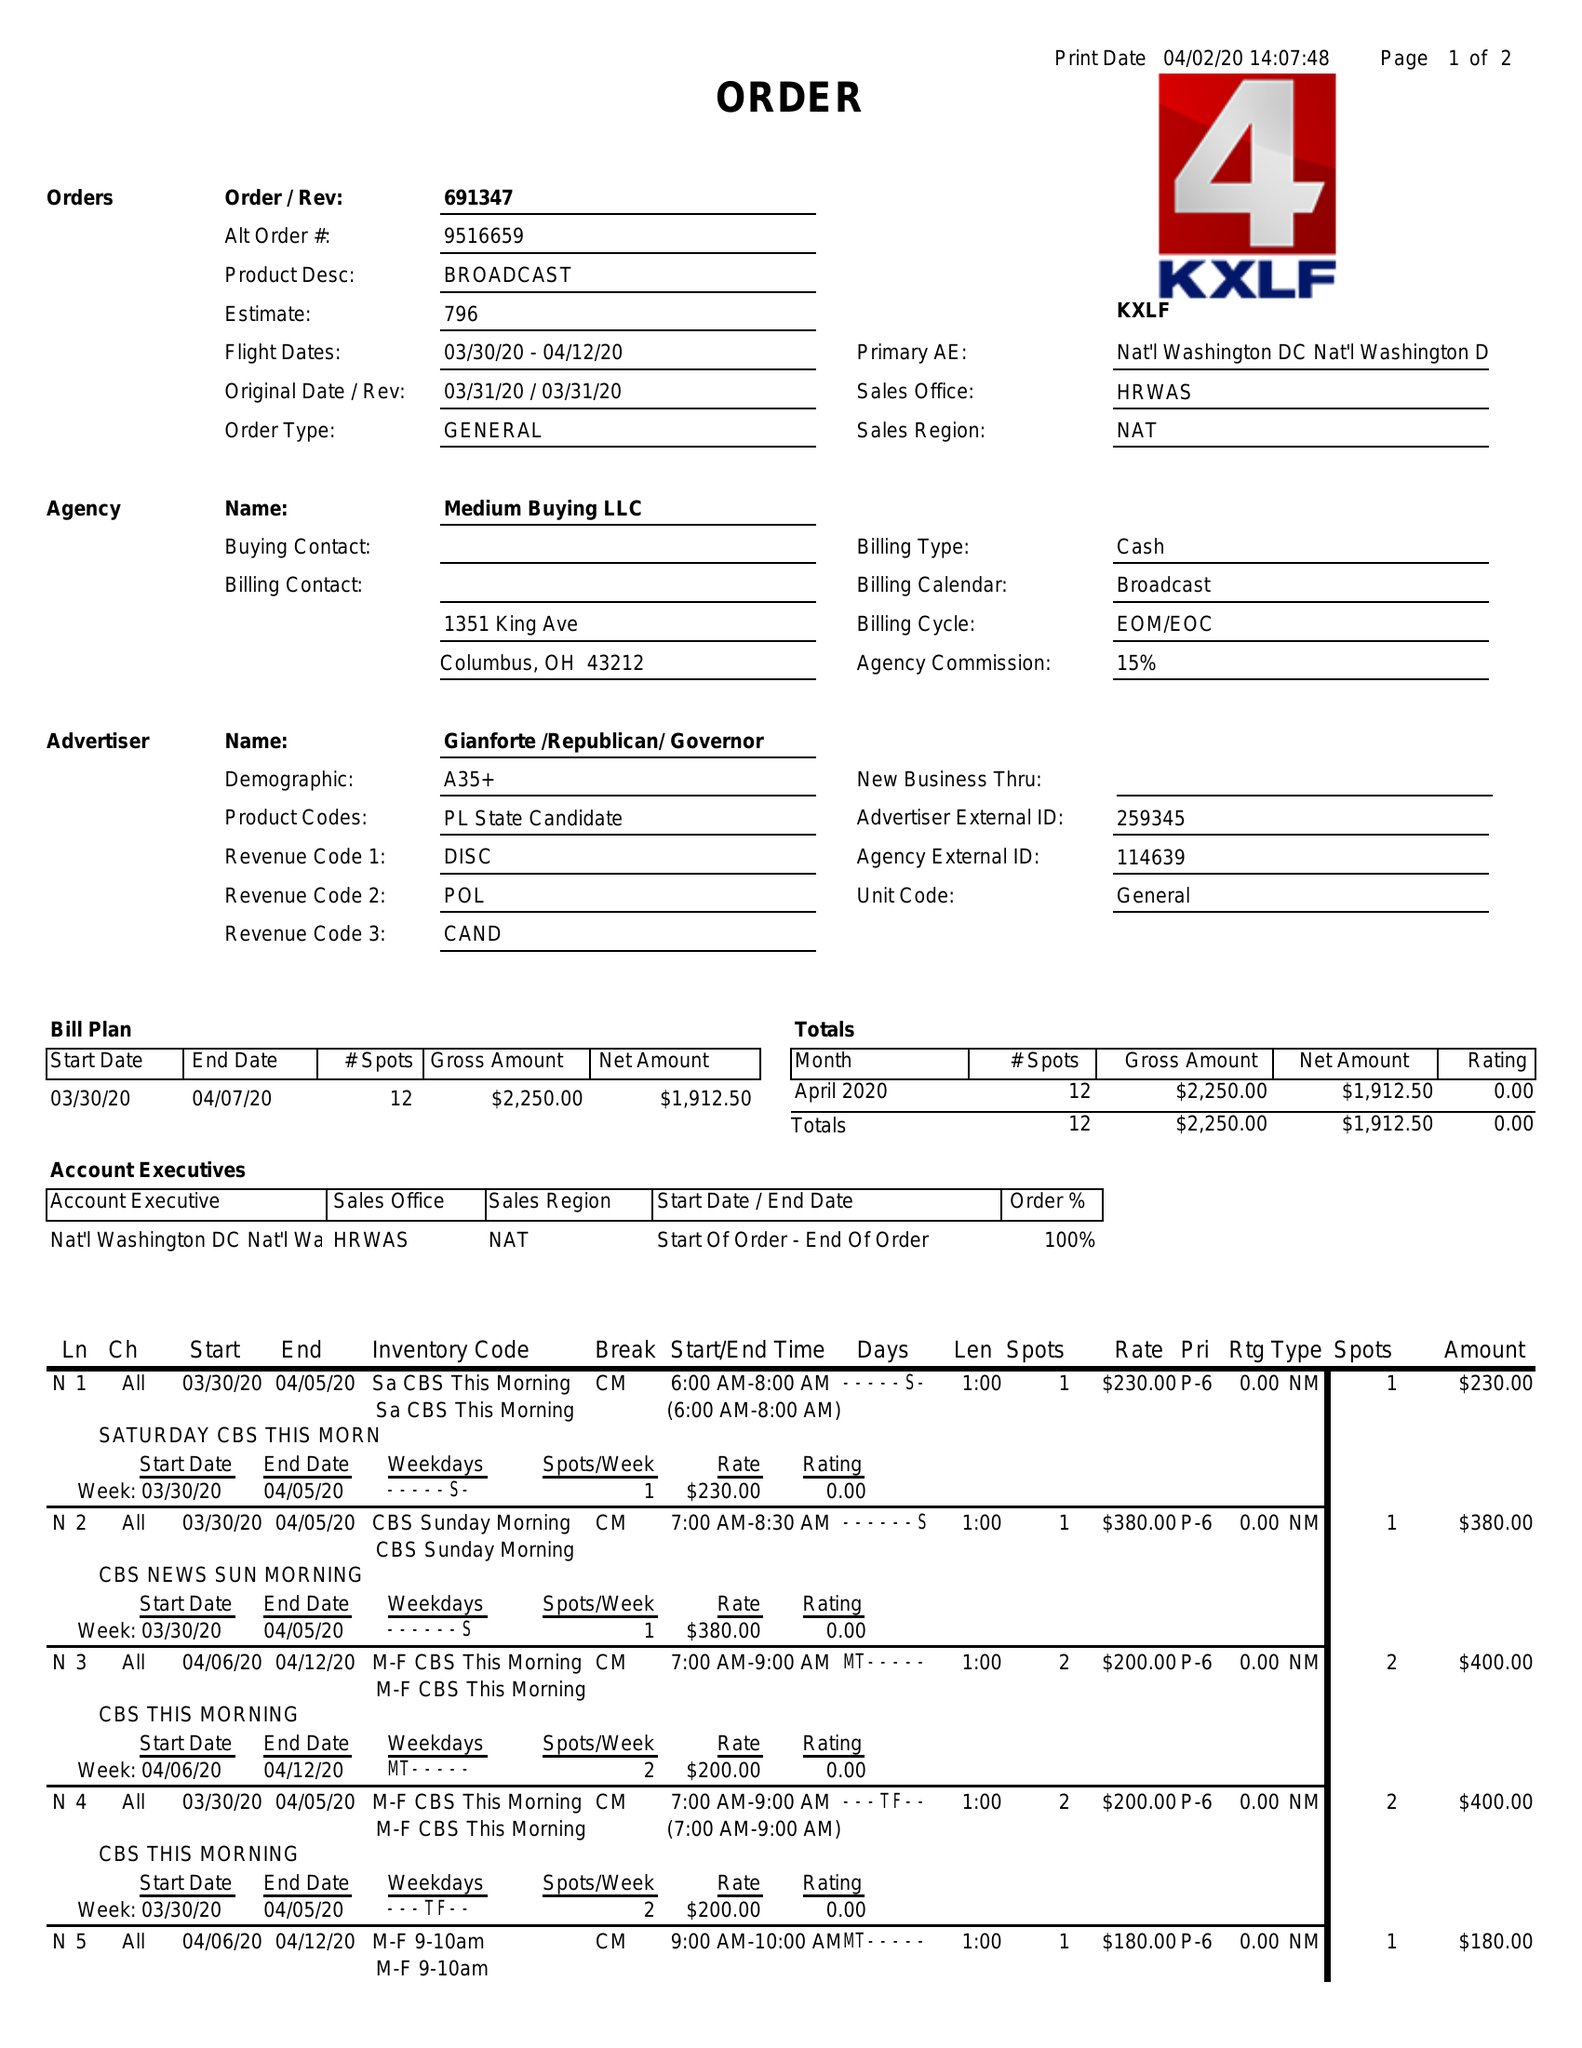What is the value for the flight_to?
Answer the question using a single word or phrase. 04/12/20 